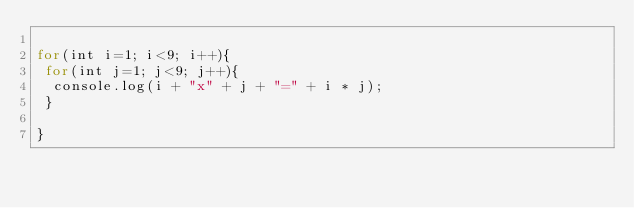Convert code to text. <code><loc_0><loc_0><loc_500><loc_500><_JavaScript_>
for(int i=1; i<9; i++){
 for(int j=1; j<9; j++){
  console.log(i + "x" + j + "=" + i * j);
 }

}</code> 